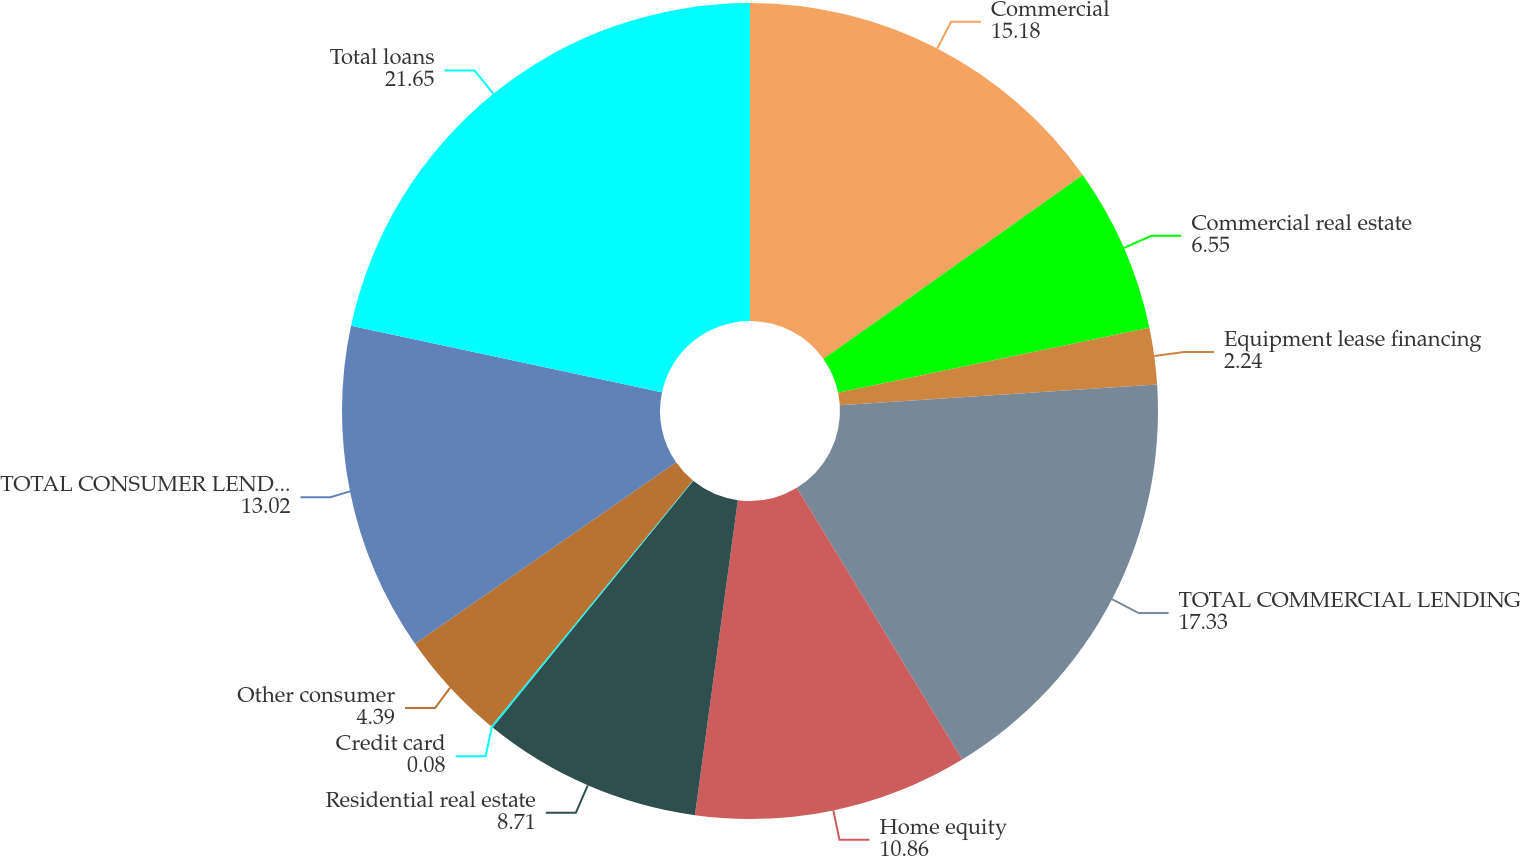<chart> <loc_0><loc_0><loc_500><loc_500><pie_chart><fcel>Commercial<fcel>Commercial real estate<fcel>Equipment lease financing<fcel>TOTAL COMMERCIAL LENDING<fcel>Home equity<fcel>Residential real estate<fcel>Credit card<fcel>Other consumer<fcel>TOTAL CONSUMER LENDING<fcel>Total loans<nl><fcel>15.18%<fcel>6.55%<fcel>2.24%<fcel>17.33%<fcel>10.86%<fcel>8.71%<fcel>0.08%<fcel>4.39%<fcel>13.02%<fcel>21.65%<nl></chart> 